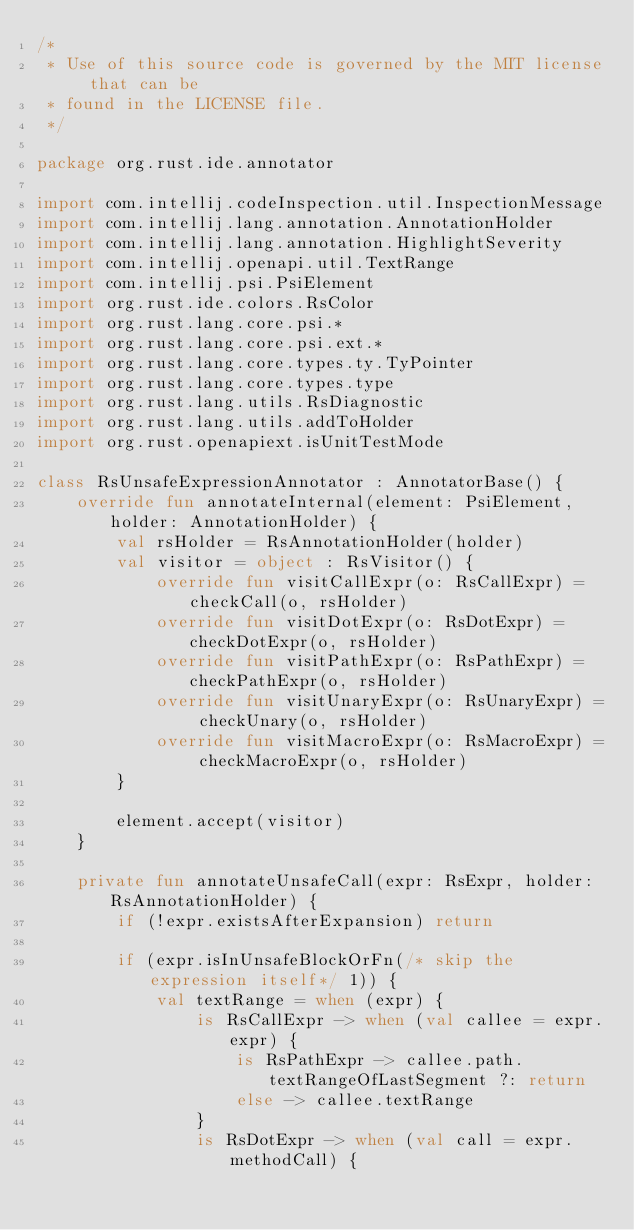<code> <loc_0><loc_0><loc_500><loc_500><_Kotlin_>/*
 * Use of this source code is governed by the MIT license that can be
 * found in the LICENSE file.
 */

package org.rust.ide.annotator

import com.intellij.codeInspection.util.InspectionMessage
import com.intellij.lang.annotation.AnnotationHolder
import com.intellij.lang.annotation.HighlightSeverity
import com.intellij.openapi.util.TextRange
import com.intellij.psi.PsiElement
import org.rust.ide.colors.RsColor
import org.rust.lang.core.psi.*
import org.rust.lang.core.psi.ext.*
import org.rust.lang.core.types.ty.TyPointer
import org.rust.lang.core.types.type
import org.rust.lang.utils.RsDiagnostic
import org.rust.lang.utils.addToHolder
import org.rust.openapiext.isUnitTestMode

class RsUnsafeExpressionAnnotator : AnnotatorBase() {
    override fun annotateInternal(element: PsiElement, holder: AnnotationHolder) {
        val rsHolder = RsAnnotationHolder(holder)
        val visitor = object : RsVisitor() {
            override fun visitCallExpr(o: RsCallExpr) = checkCall(o, rsHolder)
            override fun visitDotExpr(o: RsDotExpr) = checkDotExpr(o, rsHolder)
            override fun visitPathExpr(o: RsPathExpr) = checkPathExpr(o, rsHolder)
            override fun visitUnaryExpr(o: RsUnaryExpr) = checkUnary(o, rsHolder)
            override fun visitMacroExpr(o: RsMacroExpr) = checkMacroExpr(o, rsHolder)
        }

        element.accept(visitor)
    }

    private fun annotateUnsafeCall(expr: RsExpr, holder: RsAnnotationHolder) {
        if (!expr.existsAfterExpansion) return

        if (expr.isInUnsafeBlockOrFn(/* skip the expression itself*/ 1)) {
            val textRange = when (expr) {
                is RsCallExpr -> when (val callee = expr.expr) {
                    is RsPathExpr -> callee.path.textRangeOfLastSegment ?: return
                    else -> callee.textRange
                }
                is RsDotExpr -> when (val call = expr.methodCall) {</code> 